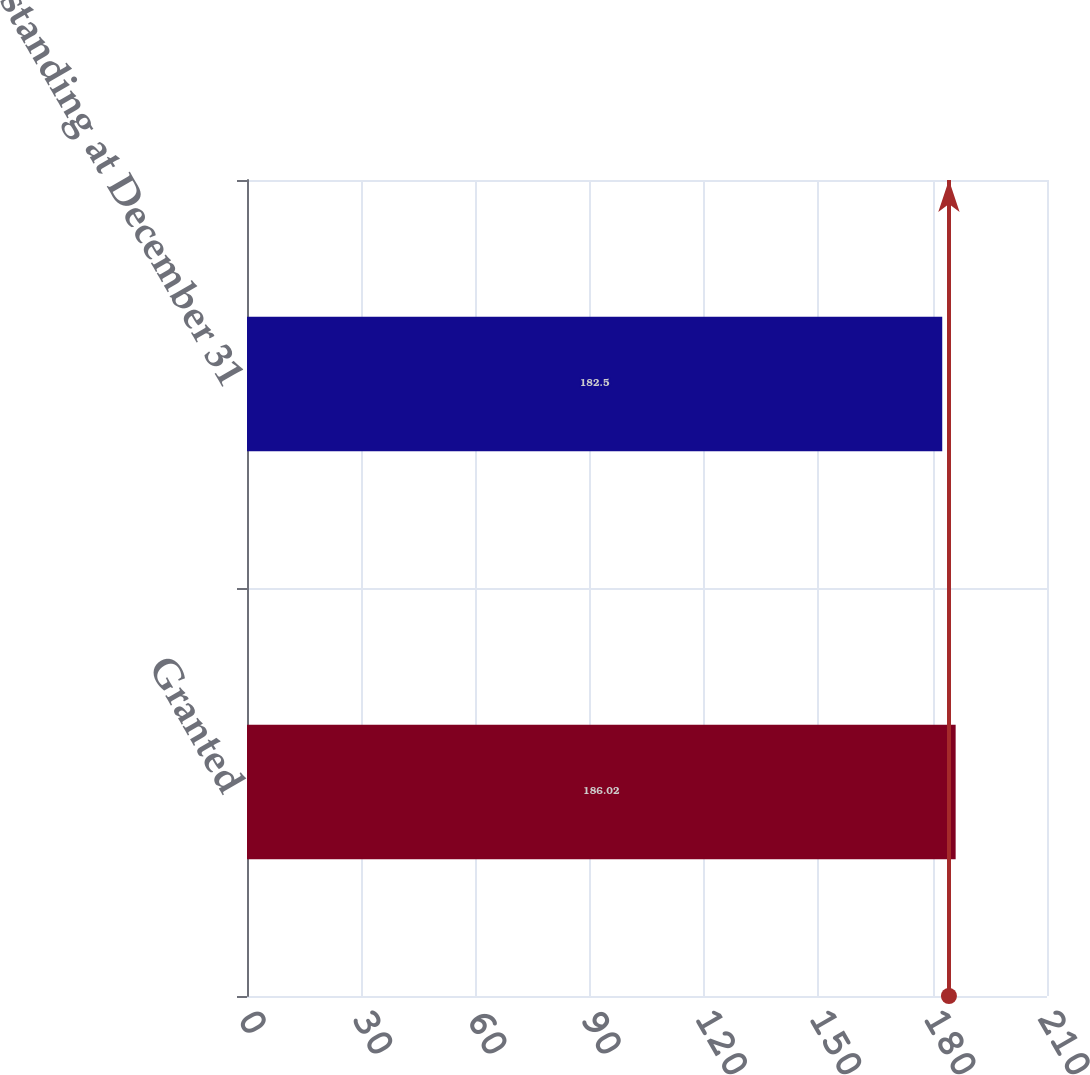<chart> <loc_0><loc_0><loc_500><loc_500><bar_chart><fcel>Granted<fcel>Outstanding at December 31<nl><fcel>186.02<fcel>182.5<nl></chart> 